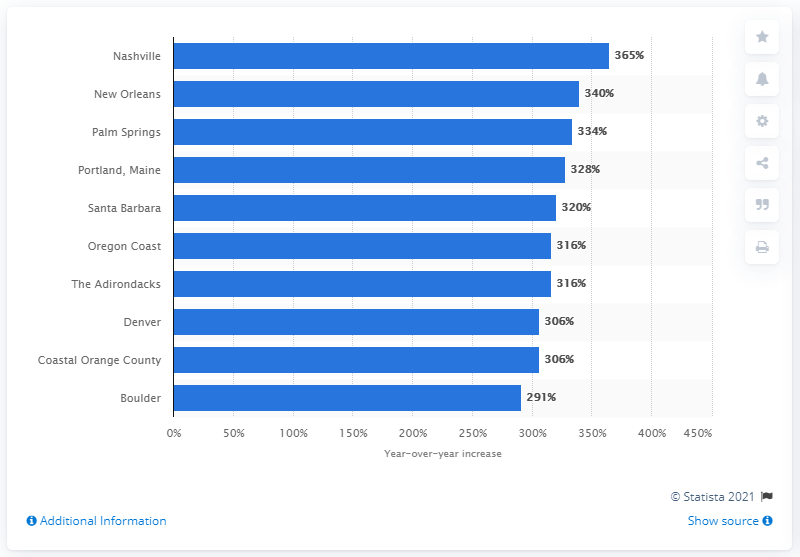List a handful of essential elements in this visual. In 2014, Nashville was the fastest growing summer travel destination in the United States. 